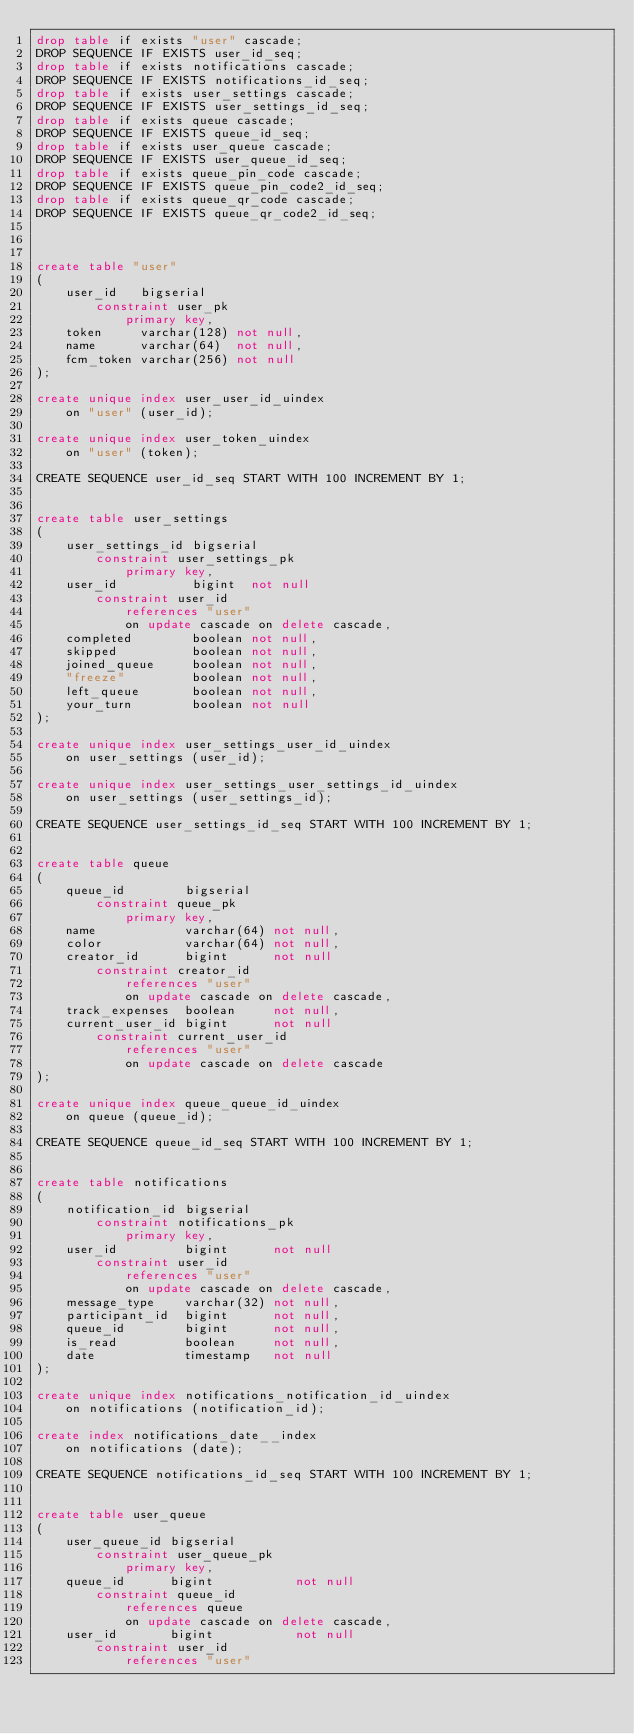Convert code to text. <code><loc_0><loc_0><loc_500><loc_500><_SQL_>drop table if exists "user" cascade;
DROP SEQUENCE IF EXISTS user_id_seq;
drop table if exists notifications cascade;
DROP SEQUENCE IF EXISTS notifications_id_seq;
drop table if exists user_settings cascade;
DROP SEQUENCE IF EXISTS user_settings_id_seq;
drop table if exists queue cascade;
DROP SEQUENCE IF EXISTS queue_id_seq;
drop table if exists user_queue cascade;
DROP SEQUENCE IF EXISTS user_queue_id_seq;
drop table if exists queue_pin_code cascade;
DROP SEQUENCE IF EXISTS queue_pin_code2_id_seq;
drop table if exists queue_qr_code cascade;
DROP SEQUENCE IF EXISTS queue_qr_code2_id_seq;



create table "user"
(
    user_id   bigserial
        constraint user_pk
            primary key,
    token     varchar(128) not null,
    name      varchar(64)  not null,
    fcm_token varchar(256) not null
);

create unique index user_user_id_uindex
    on "user" (user_id);

create unique index user_token_uindex
    on "user" (token);

CREATE SEQUENCE user_id_seq START WITH 100 INCREMENT BY 1;


create table user_settings
(
    user_settings_id bigserial
        constraint user_settings_pk
            primary key,
    user_id          bigint  not null
        constraint user_id
            references "user"
            on update cascade on delete cascade,
    completed        boolean not null,
    skipped          boolean not null,
    joined_queue     boolean not null,
    "freeze"         boolean not null,
    left_queue       boolean not null,
    your_turn        boolean not null
);

create unique index user_settings_user_id_uindex
    on user_settings (user_id);

create unique index user_settings_user_settings_id_uindex
    on user_settings (user_settings_id);

CREATE SEQUENCE user_settings_id_seq START WITH 100 INCREMENT BY 1;


create table queue
(
    queue_id        bigserial
        constraint queue_pk
            primary key,
    name            varchar(64) not null,
    color           varchar(64) not null,
    creator_id      bigint      not null
        constraint creator_id
            references "user"
            on update cascade on delete cascade,
    track_expenses  boolean     not null,
    current_user_id bigint      not null
        constraint current_user_id
            references "user"
            on update cascade on delete cascade
);

create unique index queue_queue_id_uindex
    on queue (queue_id);

CREATE SEQUENCE queue_id_seq START WITH 100 INCREMENT BY 1;


create table notifications
(
    notification_id bigserial
        constraint notifications_pk
            primary key,
    user_id         bigint      not null
        constraint user_id
            references "user"
            on update cascade on delete cascade,
    message_type    varchar(32) not null,
    participant_id  bigint      not null,
    queue_id        bigint      not null,
    is_read         boolean     not null,
    date            timestamp   not null
);

create unique index notifications_notification_id_uindex
    on notifications (notification_id);

create index notifications_date__index
    on notifications (date);

CREATE SEQUENCE notifications_id_seq START WITH 100 INCREMENT BY 1;


create table user_queue
(
    user_queue_id bigserial
        constraint user_queue_pk
            primary key,
    queue_id      bigint           not null
        constraint queue_id
            references queue
            on update cascade on delete cascade,
    user_id       bigint           not null
        constraint user_id
            references "user"</code> 